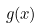Convert formula to latex. <formula><loc_0><loc_0><loc_500><loc_500>g ( x )</formula> 